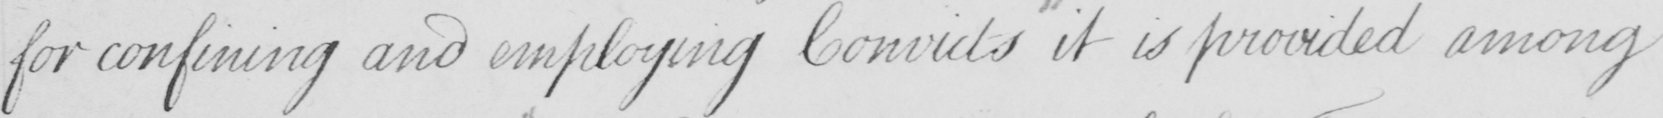What is written in this line of handwriting? for confining and employing Convicts it is provided among 